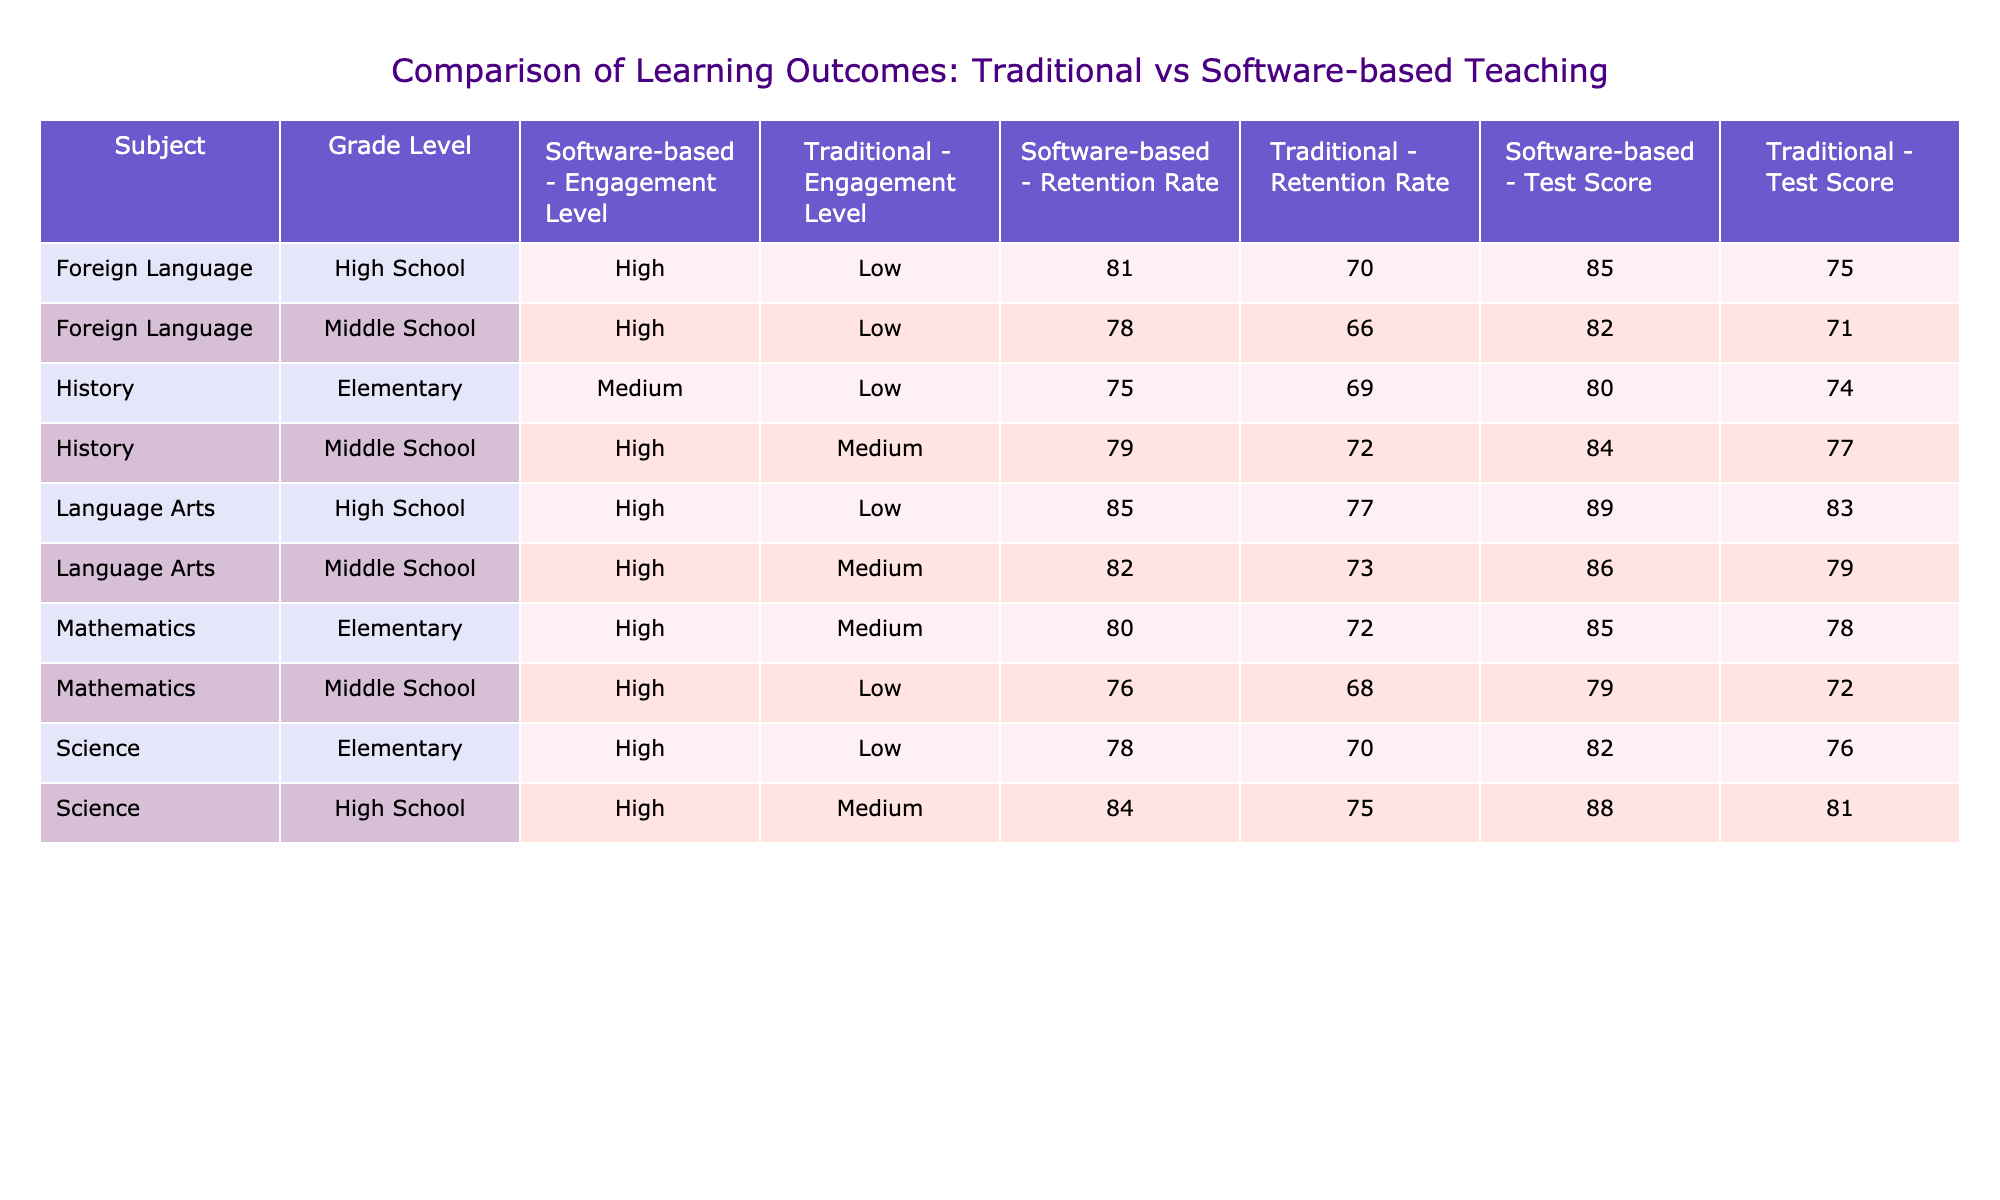What is the highest test score recorded in the software-based teaching method? The table shows test scores for different subjects and grade levels under the software-based teaching method. Scanning through these scores, I identify the highest, which is 89 in Language Arts for High School.
Answer: 89 What is the retention rate for Mathematics in the traditional teaching method at the Middle School level? Looking at the row for Mathematics under the Traditional teaching method for Middle School, the retention rate is listed as 68%.
Answer: 68% Which subject showed the greatest difference in test scores between traditional and software-based methods at the Elementary level? For the Elementary level, Mathematics had scores of 78 (traditional) and 85 (software-based), resulting in a difference of 7 points. In Science, the scores were 76 (traditional) and 82 (software-based), with a difference of 6 points. The greatest difference is thus 7 points in Mathematics.
Answer: Mathematics with a difference of 7 points Is the engagement level for the software-based teaching method consistently high across all subjects? Looking at the engagement levels for software-based teaching across subjects, Mathematics, Science, Language Arts, and History all show a high engagement level. Hence, the statement is true.
Answer: Yes What is the average test score for traditional teaching methods across all subjects? To find the average, I first sum the test scores for traditional methods: 78 (Math) + 72 (Math) + 81 (Science) + 76 (Science) + 79 (Language Arts) + 83 (Language Arts) + 74 (History) + 77 (History) + 75 (Foreign Language) + 71 (Foreign Language) =  786. There are 10 scores, making the average 786/10 = 78.6.
Answer: 78.6 In which grade level does software-based teaching have the highest average retention rate, and what is that rate? I will find the retention rates for software-based methods at each grade: Elementary (80% for Mathematics, 78% for Science, and 75% for History) averages to (80 + 78 + 75) / 3 = 77.67%. For Middle School (79% for History and 82% for Foreign Language), the average is (79 + 78) / 2 = 78.5%. At High School (84% for Science and 85% for Foreign Language), the average is (84 + 85) / 2 = 84.5%. Comparing all averages, the highest is 84.5% for High School.
Answer: High School with a retention rate of 84.5% Is there any subject where the software-based teaching method had a lower retention rate than the traditional method? Reviewing the retention rates, in Mathematics, the traditional method has 72% versus 80% for software-based, in Science traditional is 75% versus 84% software-based, Language Arts shows 77% for traditional versus 85% for software-based, History is 69% versus 75%, and Foreign Language shows 70% versus 81%. In all cases, software-based rates are higher than traditional.
Answer: No 